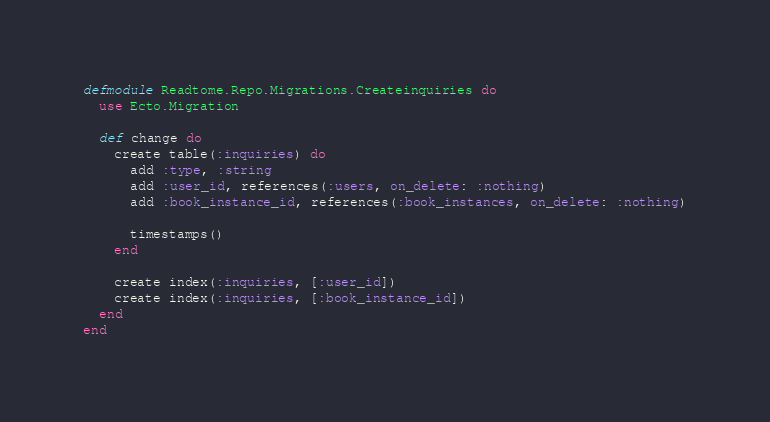Convert code to text. <code><loc_0><loc_0><loc_500><loc_500><_Elixir_>defmodule Readtome.Repo.Migrations.Createinquiries do
  use Ecto.Migration

  def change do
    create table(:inquiries) do
      add :type, :string
      add :user_id, references(:users, on_delete: :nothing)
      add :book_instance_id, references(:book_instances, on_delete: :nothing)

      timestamps()
    end

    create index(:inquiries, [:user_id])
    create index(:inquiries, [:book_instance_id])
  end
end
</code> 